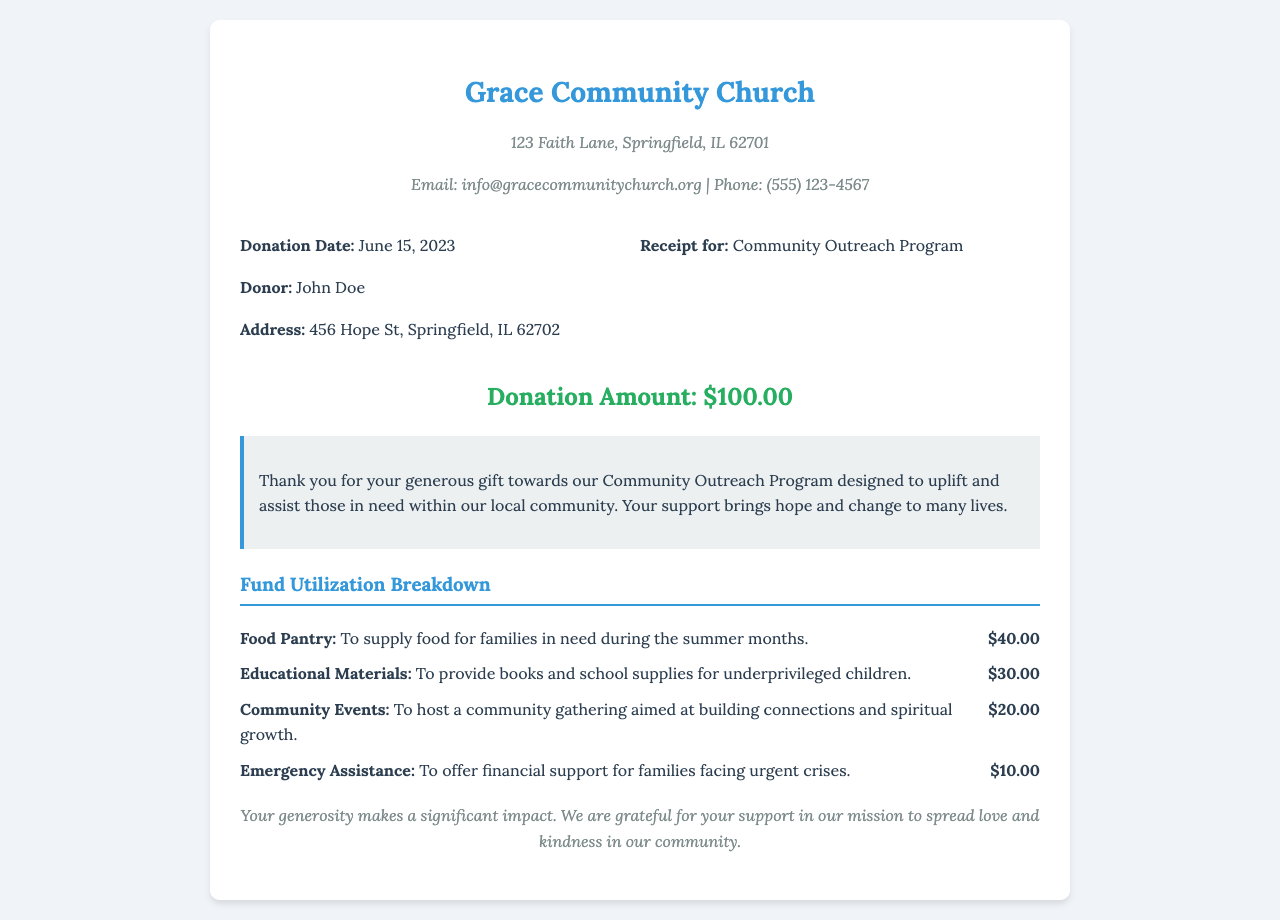What is the donation date? The donation date is specifically mentioned in the document as June 15, 2023.
Answer: June 15, 2023 Who is the donor? The receipt specifies the donor's name as John Doe.
Answer: John Doe What is the donation amount? The document indicates a donation amount of $100.00.
Answer: $100.00 What is the purpose of the donation? The receipt states the donation is for the Community Outreach Program.
Answer: Community Outreach Program How much is allocated for the Food Pantry? The breakdown section provides the amount allocated for the Food Pantry, which is $40.00.
Answer: $40.00 What percentage of the donation goes to Emergency Assistance? The Emergency Assistance receives $10.00 out of a $100.00 donation, which corresponds to 10%.
Answer: 10% What is one of the items funded by the donation? The document lists several items funded, including Educational Materials, which is one of them.
Answer: Educational Materials How many areas does the fund utilization breakdown cover? The breakdown section lists four distinct areas where the funds will be utilized.
Answer: Four What message does the church convey to the donor? The message expresses gratitude for the donor's support, emphasizing its impact on the community.
Answer: Thank you for your generous gift 